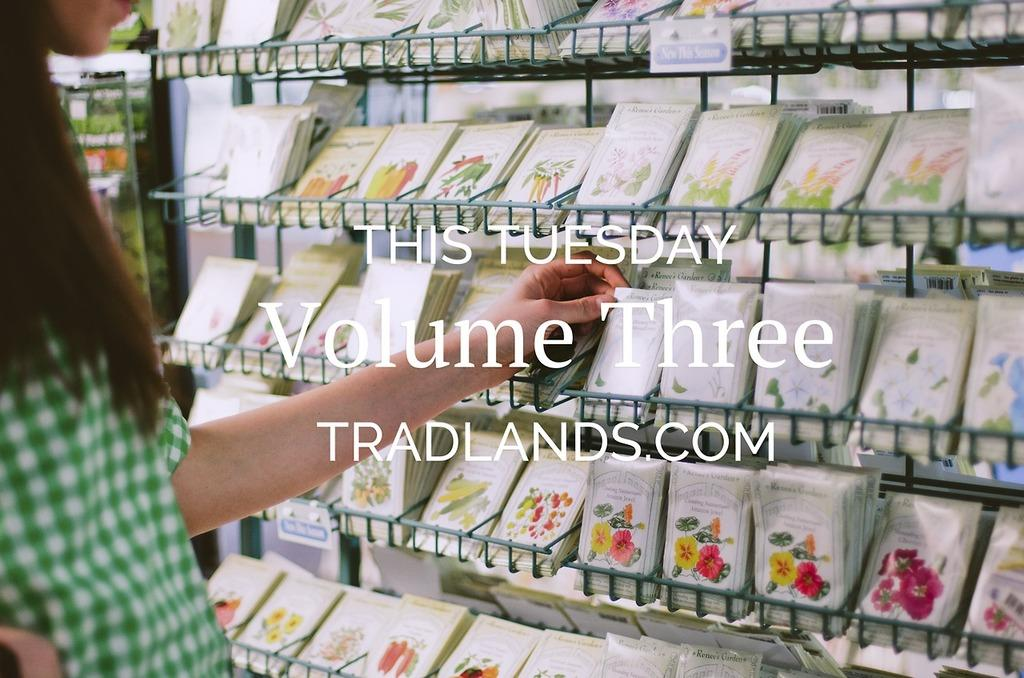<image>
Render a clear and concise summary of the photo. Volume Three, This Tuesday, Tradlands.com is captioned over this photo. 